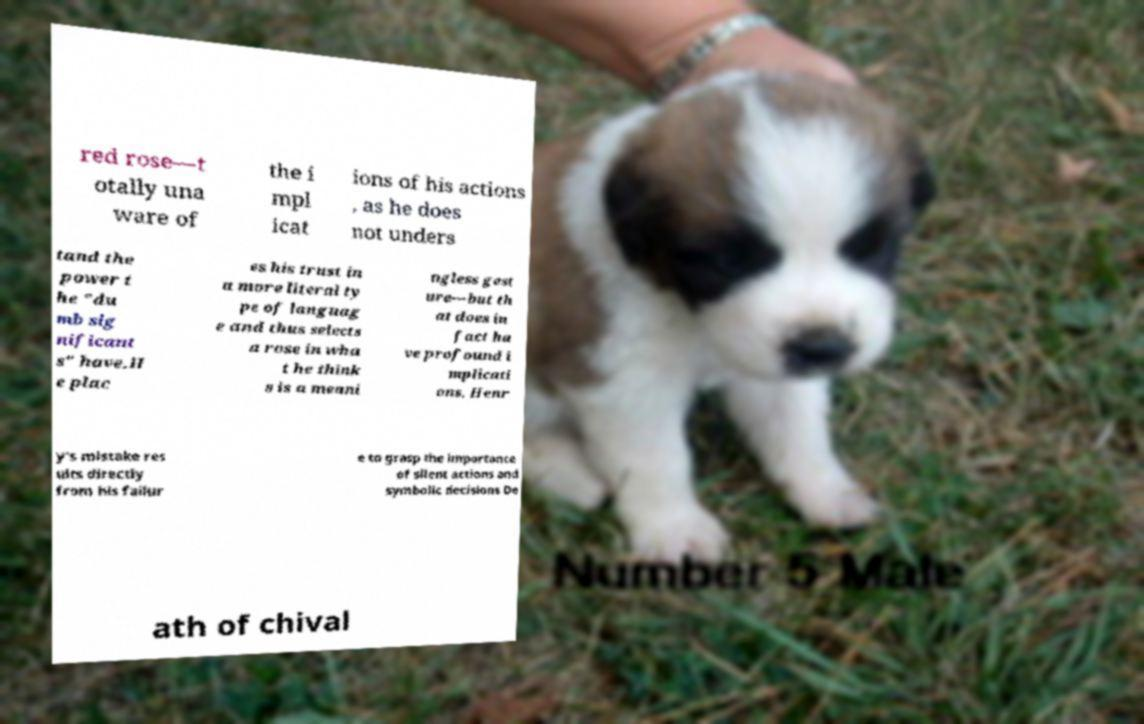Could you extract and type out the text from this image? red rose—t otally una ware of the i mpl icat ions of his actions , as he does not unders tand the power t he "du mb sig nificant s" have.H e plac es his trust in a more literal ty pe of languag e and thus selects a rose in wha t he think s is a meani ngless gest ure—but th at does in fact ha ve profound i mplicati ons. Henr y's mistake res ults directly from his failur e to grasp the importance of silent actions and symbolic decisions De ath of chival 